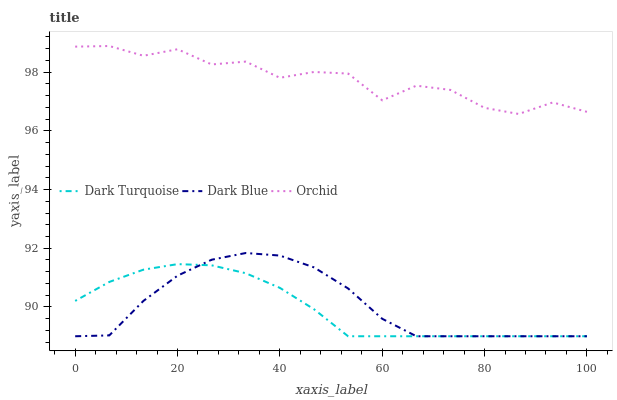Does Dark Turquoise have the minimum area under the curve?
Answer yes or no. Yes. Does Orchid have the maximum area under the curve?
Answer yes or no. Yes. Does Dark Blue have the minimum area under the curve?
Answer yes or no. No. Does Dark Blue have the maximum area under the curve?
Answer yes or no. No. Is Dark Turquoise the smoothest?
Answer yes or no. Yes. Is Orchid the roughest?
Answer yes or no. Yes. Is Dark Blue the smoothest?
Answer yes or no. No. Is Dark Blue the roughest?
Answer yes or no. No. Does Dark Turquoise have the lowest value?
Answer yes or no. Yes. Does Orchid have the lowest value?
Answer yes or no. No. Does Orchid have the highest value?
Answer yes or no. Yes. Does Dark Blue have the highest value?
Answer yes or no. No. Is Dark Blue less than Orchid?
Answer yes or no. Yes. Is Orchid greater than Dark Blue?
Answer yes or no. Yes. Does Dark Turquoise intersect Dark Blue?
Answer yes or no. Yes. Is Dark Turquoise less than Dark Blue?
Answer yes or no. No. Is Dark Turquoise greater than Dark Blue?
Answer yes or no. No. Does Dark Blue intersect Orchid?
Answer yes or no. No. 